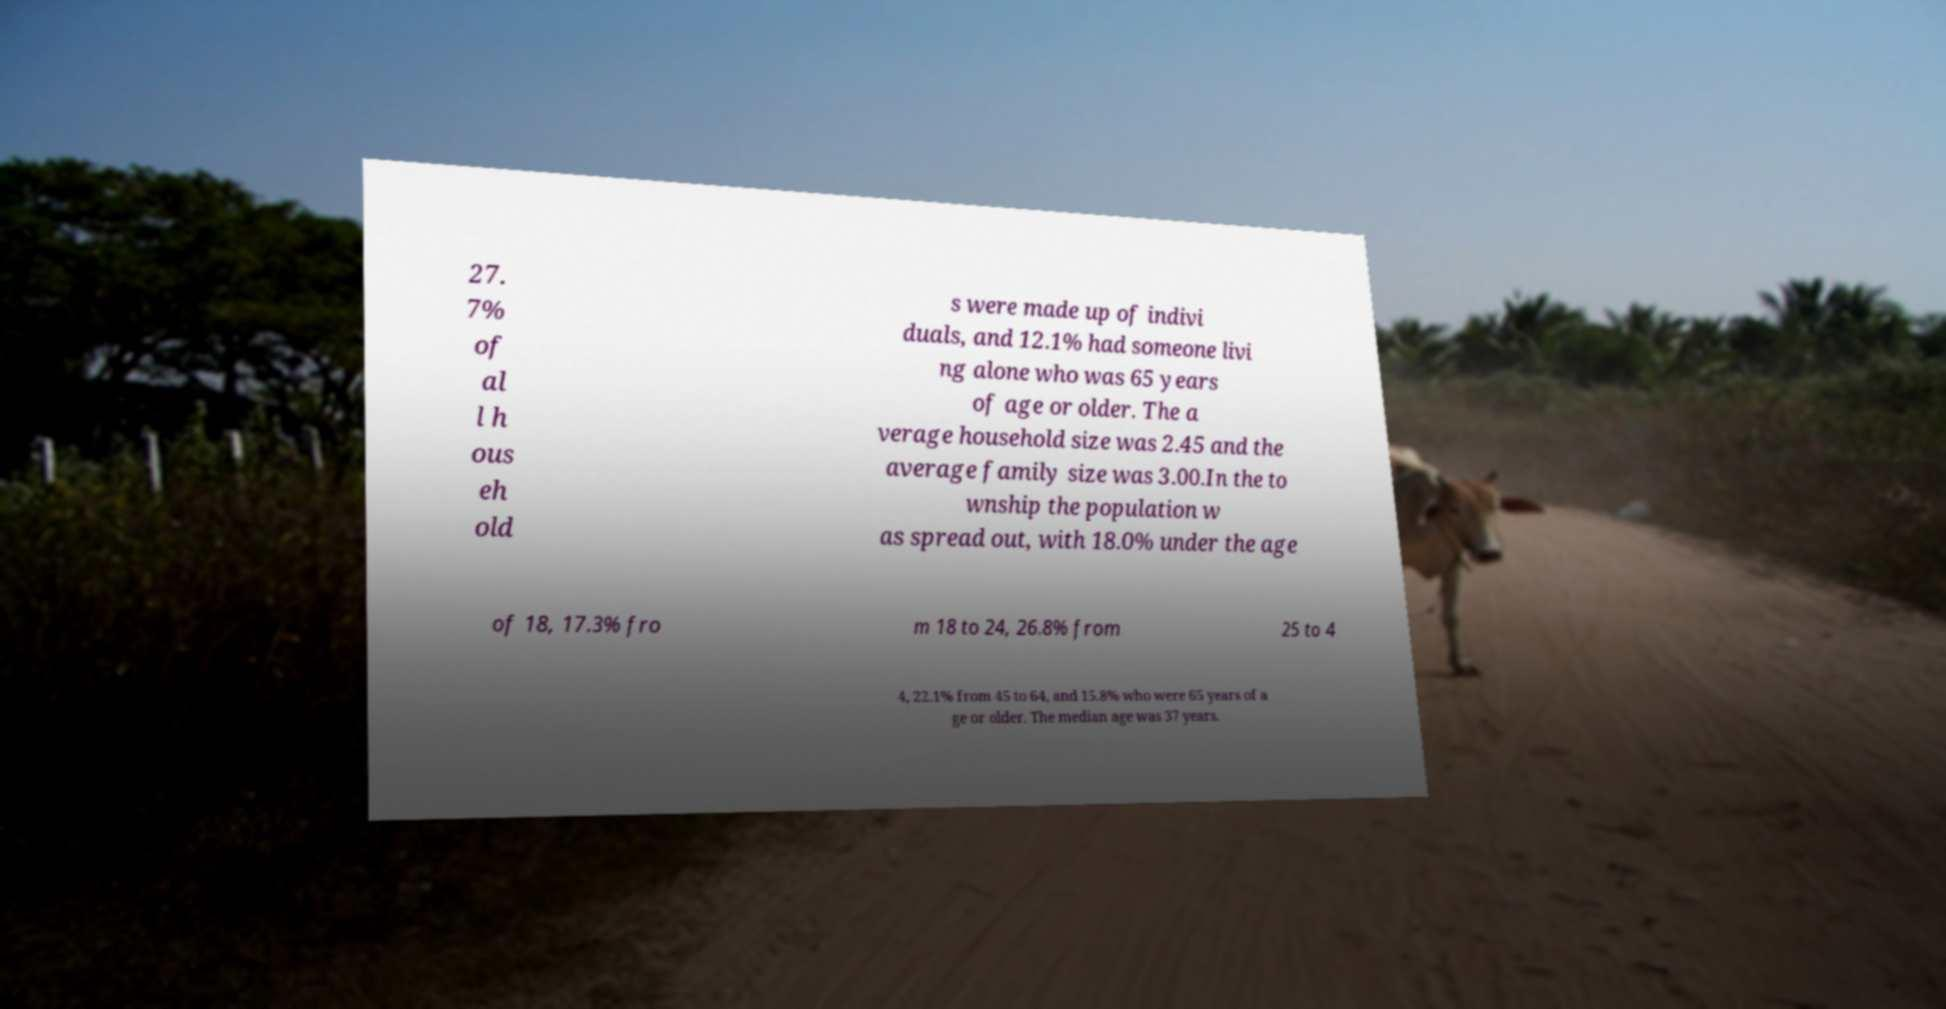Please identify and transcribe the text found in this image. 27. 7% of al l h ous eh old s were made up of indivi duals, and 12.1% had someone livi ng alone who was 65 years of age or older. The a verage household size was 2.45 and the average family size was 3.00.In the to wnship the population w as spread out, with 18.0% under the age of 18, 17.3% fro m 18 to 24, 26.8% from 25 to 4 4, 22.1% from 45 to 64, and 15.8% who were 65 years of a ge or older. The median age was 37 years. 